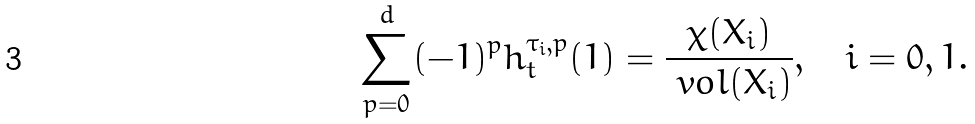<formula> <loc_0><loc_0><loc_500><loc_500>\sum _ { p = 0 } ^ { d } ( - 1 ) ^ { p } h _ { t } ^ { \tau _ { i } , p } ( 1 ) = \frac { \chi ( X _ { i } ) } { \ v o l ( X _ { i } ) } , \quad i = 0 , 1 .</formula> 